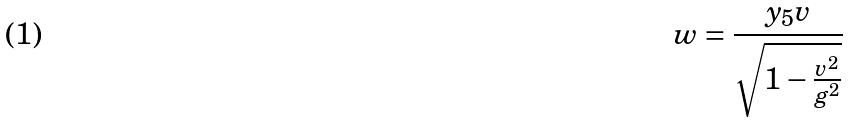<formula> <loc_0><loc_0><loc_500><loc_500>w = \frac { y _ { 5 } v } { \sqrt { 1 - \frac { v ^ { 2 } } { g ^ { 2 } } } }</formula> 